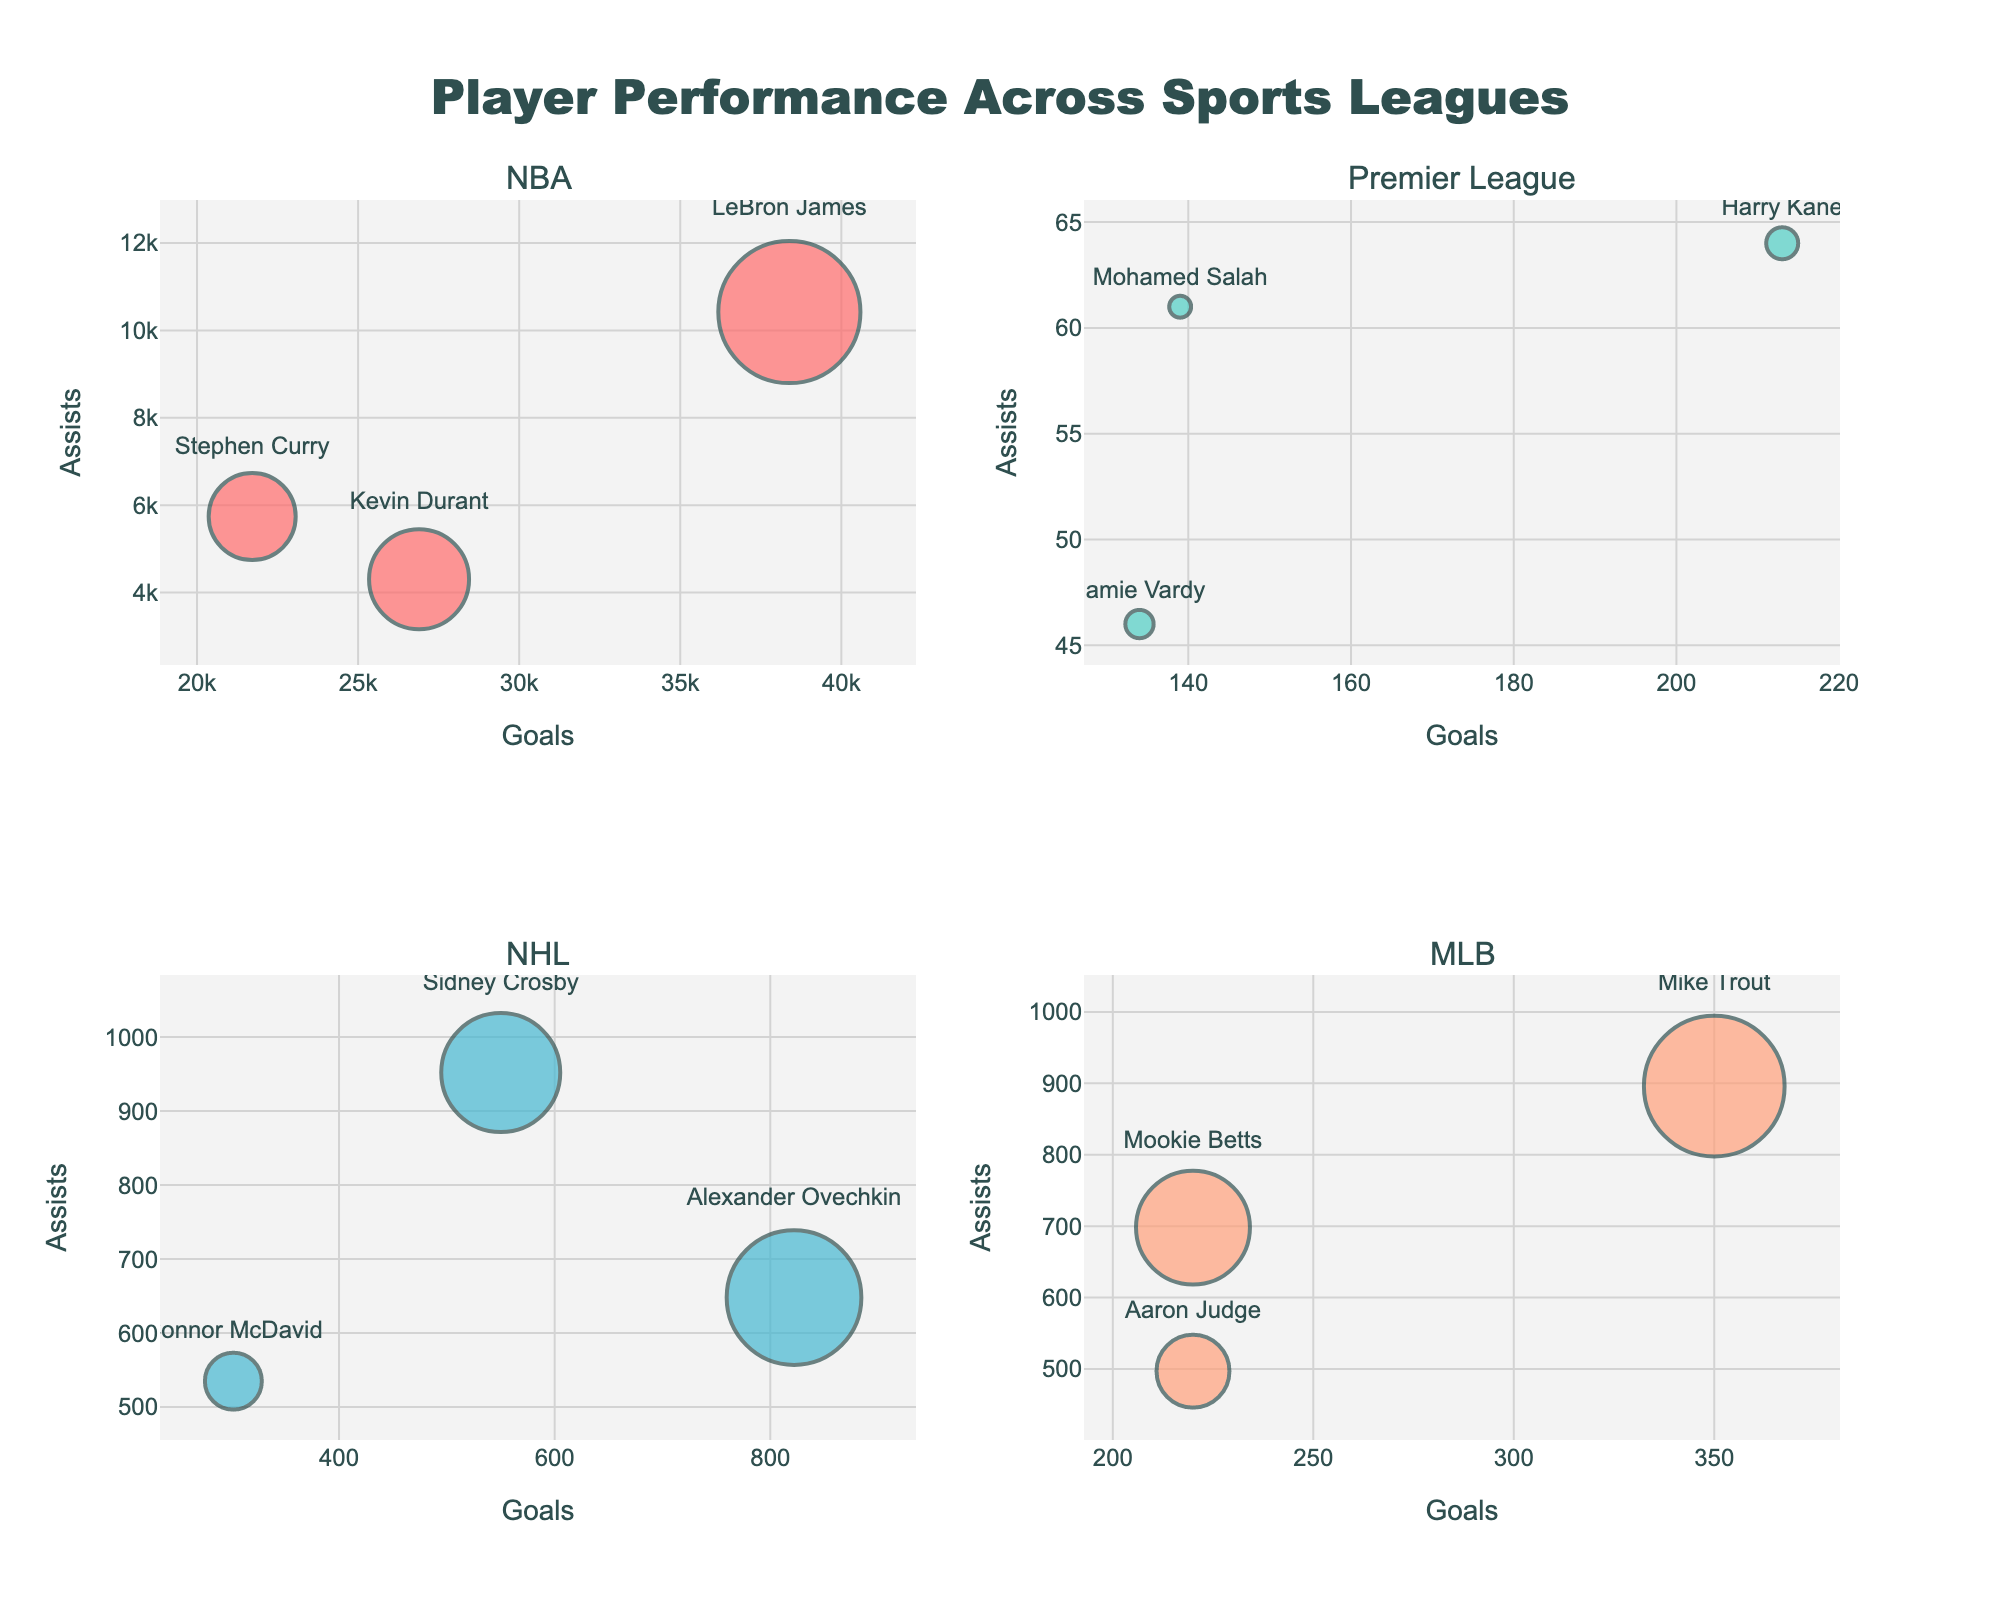What is the title of the figure? The title is usually placed at the top center of the chart and describes what the chart represents. In this case, the title is "Player Performance Across Sports Leagues".
Answer: Player Performance Across Sports Leagues How many players are displayed in the "NBA" subplot? Within the "NBA" subplot panel, count the number of individual bubble points that denote players. Each point in the NBA subplot represents a different player.
Answer: 3 Which player in the "Premier League" subplot has the highest number of assists? Examine the labels and hover text information to identify the player with the highest y-axis value in the "Premier League" subplot.
Answer: Mohamed Salah Who has more goals in the "NHL": Alexander Ovechkin or Connor McDavid? Compare the x-axis positions of Alexander Ovechkin and Connor McDavid in the NHL subplot. The player whose bubble is further to the right has more goals.
Answer: Alexander Ovechkin What is the size of Sidney Crosby's bubble in the "NHL" subplot and what does it represent? Look at the bubble size in the NHL subplot for Sidney Crosby. Bubble size indicates Games Played, so check the provided data for Sidney Crosby's Games Played value and notice that the bubble size correlates with this value.
Answer: 59.5 (Size represents 1190 games / 20) Which player in the "MLB" subplot has the smallest number of assists? Identify the player with the lowest y-axis value in the "MLB" subplot by examining their bubbles and labels.
Answer: Aaron Judge Compare the average number of goals scored by players in the "Premier League" and the "MLB". Calculate the average goals for Premier League (213 + 139 + 134) / 3 and compare it with the average goals for MLB (350 + 220 + 220) / 3. The average for Premier League is (213 + 139 + 134) / 3 = 162. The average for MLB is (350 + 220 + 220) / 3 = 263.33.
Answer: MLB has a higher average Which league has the player with the most assists and who is that player? Identify the player with the highest y-axis value across all subplots which indicate assists and note the corresponding league.
Answer: Sidney Crosby, NHL How many total games have been played by players shown in "NBA" subplot? Sum the Games Played values for all players in the NBA subplot. (1421 for LeBron James, 870 for Stephen Curry, 1000 for Kevin Durant)
Answer: 3291 Which player in the "Premier League" subplot has the biggest bubble and what does it signify? Identify the player with the largest bubble in the Premier League subplot and correlate the size to the Games Played from the data provided.
Answer: Harry Kane, represents 320 games 